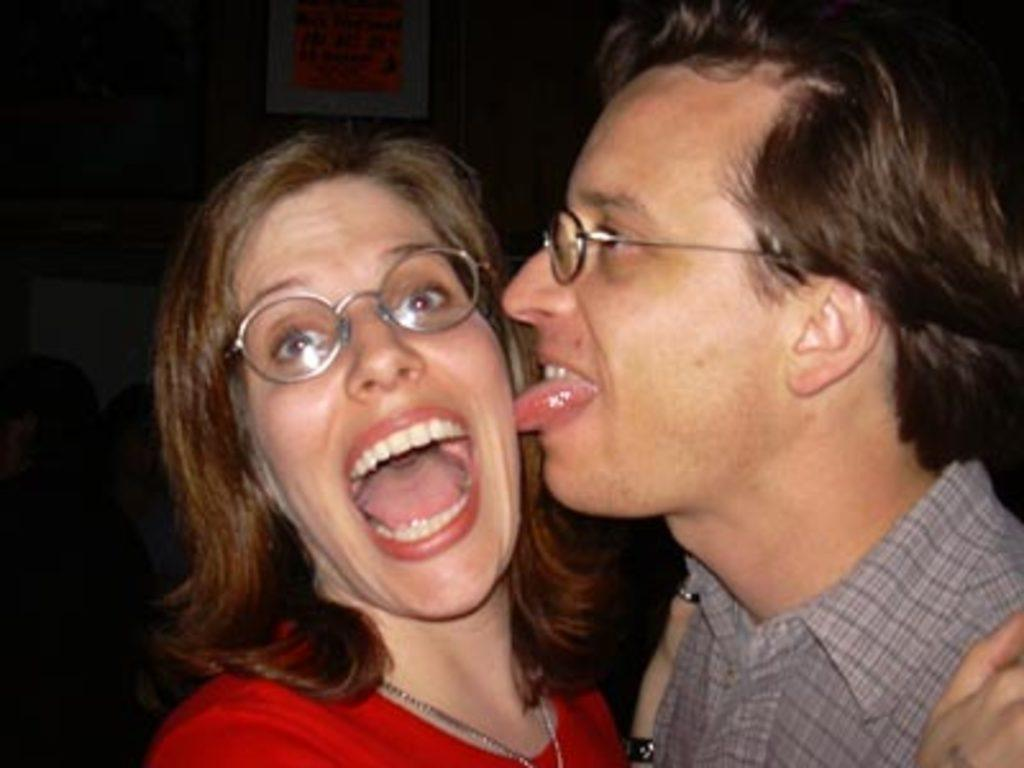Where is the person located in the image? The person is in the right corner of the image. What is the person doing in the image? The person is licking the cheek of a woman in front of him. Can you describe any other objects or people in the background of the image? Unfortunately, the provided facts do not mention any other objects or people in the background of the image. How does the baby feel about the person licking the woman's cheek in the image? There is no baby present in the image, so it is not possible to determine how a baby might feel about the person's action. 